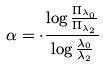Convert formula to latex. <formula><loc_0><loc_0><loc_500><loc_500>\alpha = \cdot \frac { \log \frac { \Pi _ { \lambda _ { 0 } } } { \Pi _ { \lambda _ { 2 } } } } { \log \frac { \lambda _ { 0 } } { \lambda _ { 2 } } }</formula> 